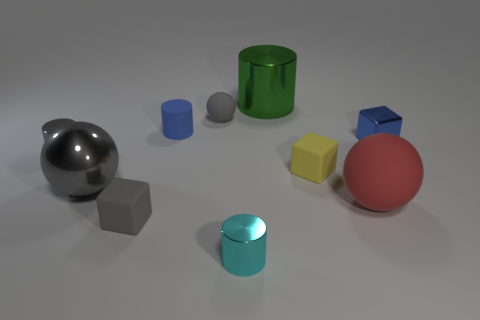Subtract all rubber balls. How many balls are left? 1 Subtract all green cylinders. How many cylinders are left? 3 Subtract 1 cylinders. How many cylinders are left? 3 Subtract all cylinders. How many objects are left? 6 Subtract all blue blocks. How many gray spheres are left? 2 Add 1 cyan metallic objects. How many cyan metallic objects exist? 2 Subtract 0 yellow cylinders. How many objects are left? 10 Subtract all blue balls. Subtract all blue blocks. How many balls are left? 3 Subtract all large red rubber things. Subtract all big balls. How many objects are left? 7 Add 5 small blue metal objects. How many small blue metal objects are left? 6 